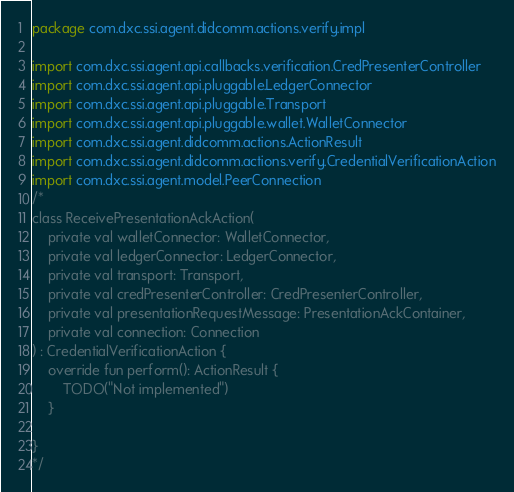<code> <loc_0><loc_0><loc_500><loc_500><_Kotlin_>package com.dxc.ssi.agent.didcomm.actions.verify.impl

import com.dxc.ssi.agent.api.callbacks.verification.CredPresenterController
import com.dxc.ssi.agent.api.pluggable.LedgerConnector
import com.dxc.ssi.agent.api.pluggable.Transport
import com.dxc.ssi.agent.api.pluggable.wallet.WalletConnector
import com.dxc.ssi.agent.didcomm.actions.ActionResult
import com.dxc.ssi.agent.didcomm.actions.verify.CredentialVerificationAction
import com.dxc.ssi.agent.model.PeerConnection
/*
class ReceivePresentationAckAction(
    private val walletConnector: WalletConnector,
    private val ledgerConnector: LedgerConnector,
    private val transport: Transport,
    private val credPresenterController: CredPresenterController,
    private val presentationRequestMessage: PresentationAckContainer,
    private val connection: Connection
) : CredentialVerificationAction {
    override fun perform(): ActionResult {
        TODO("Not implemented")
    }

}
*/</code> 